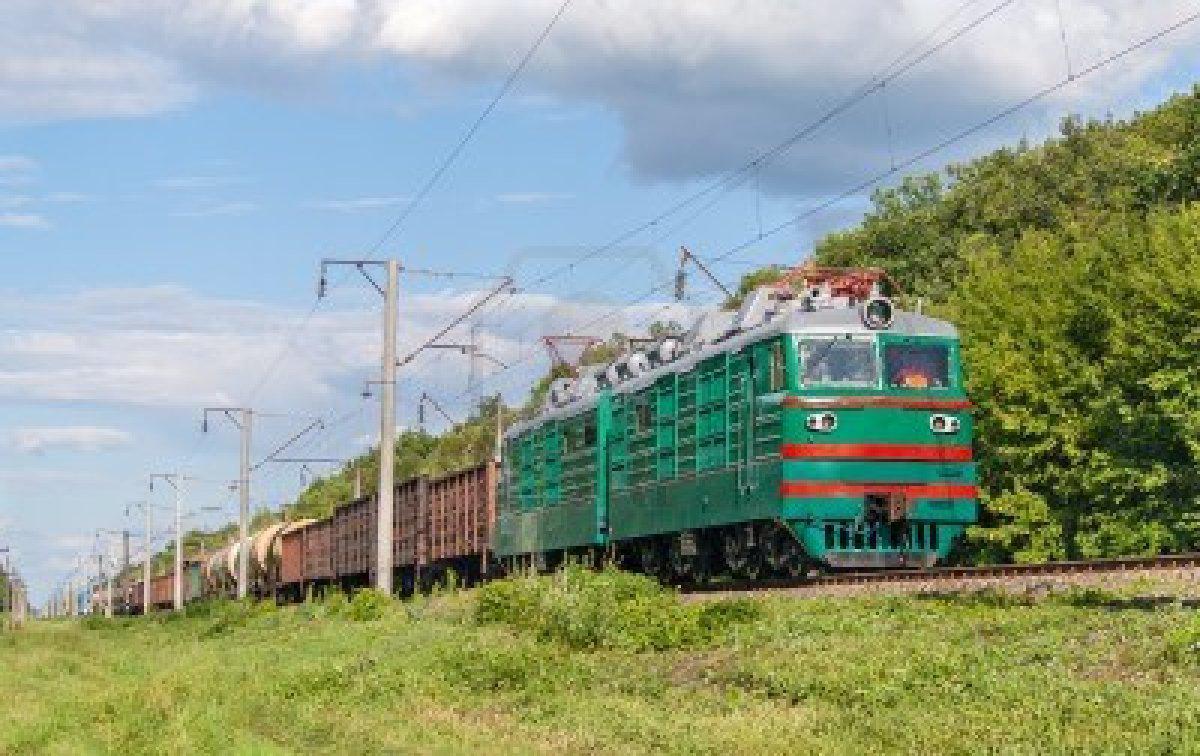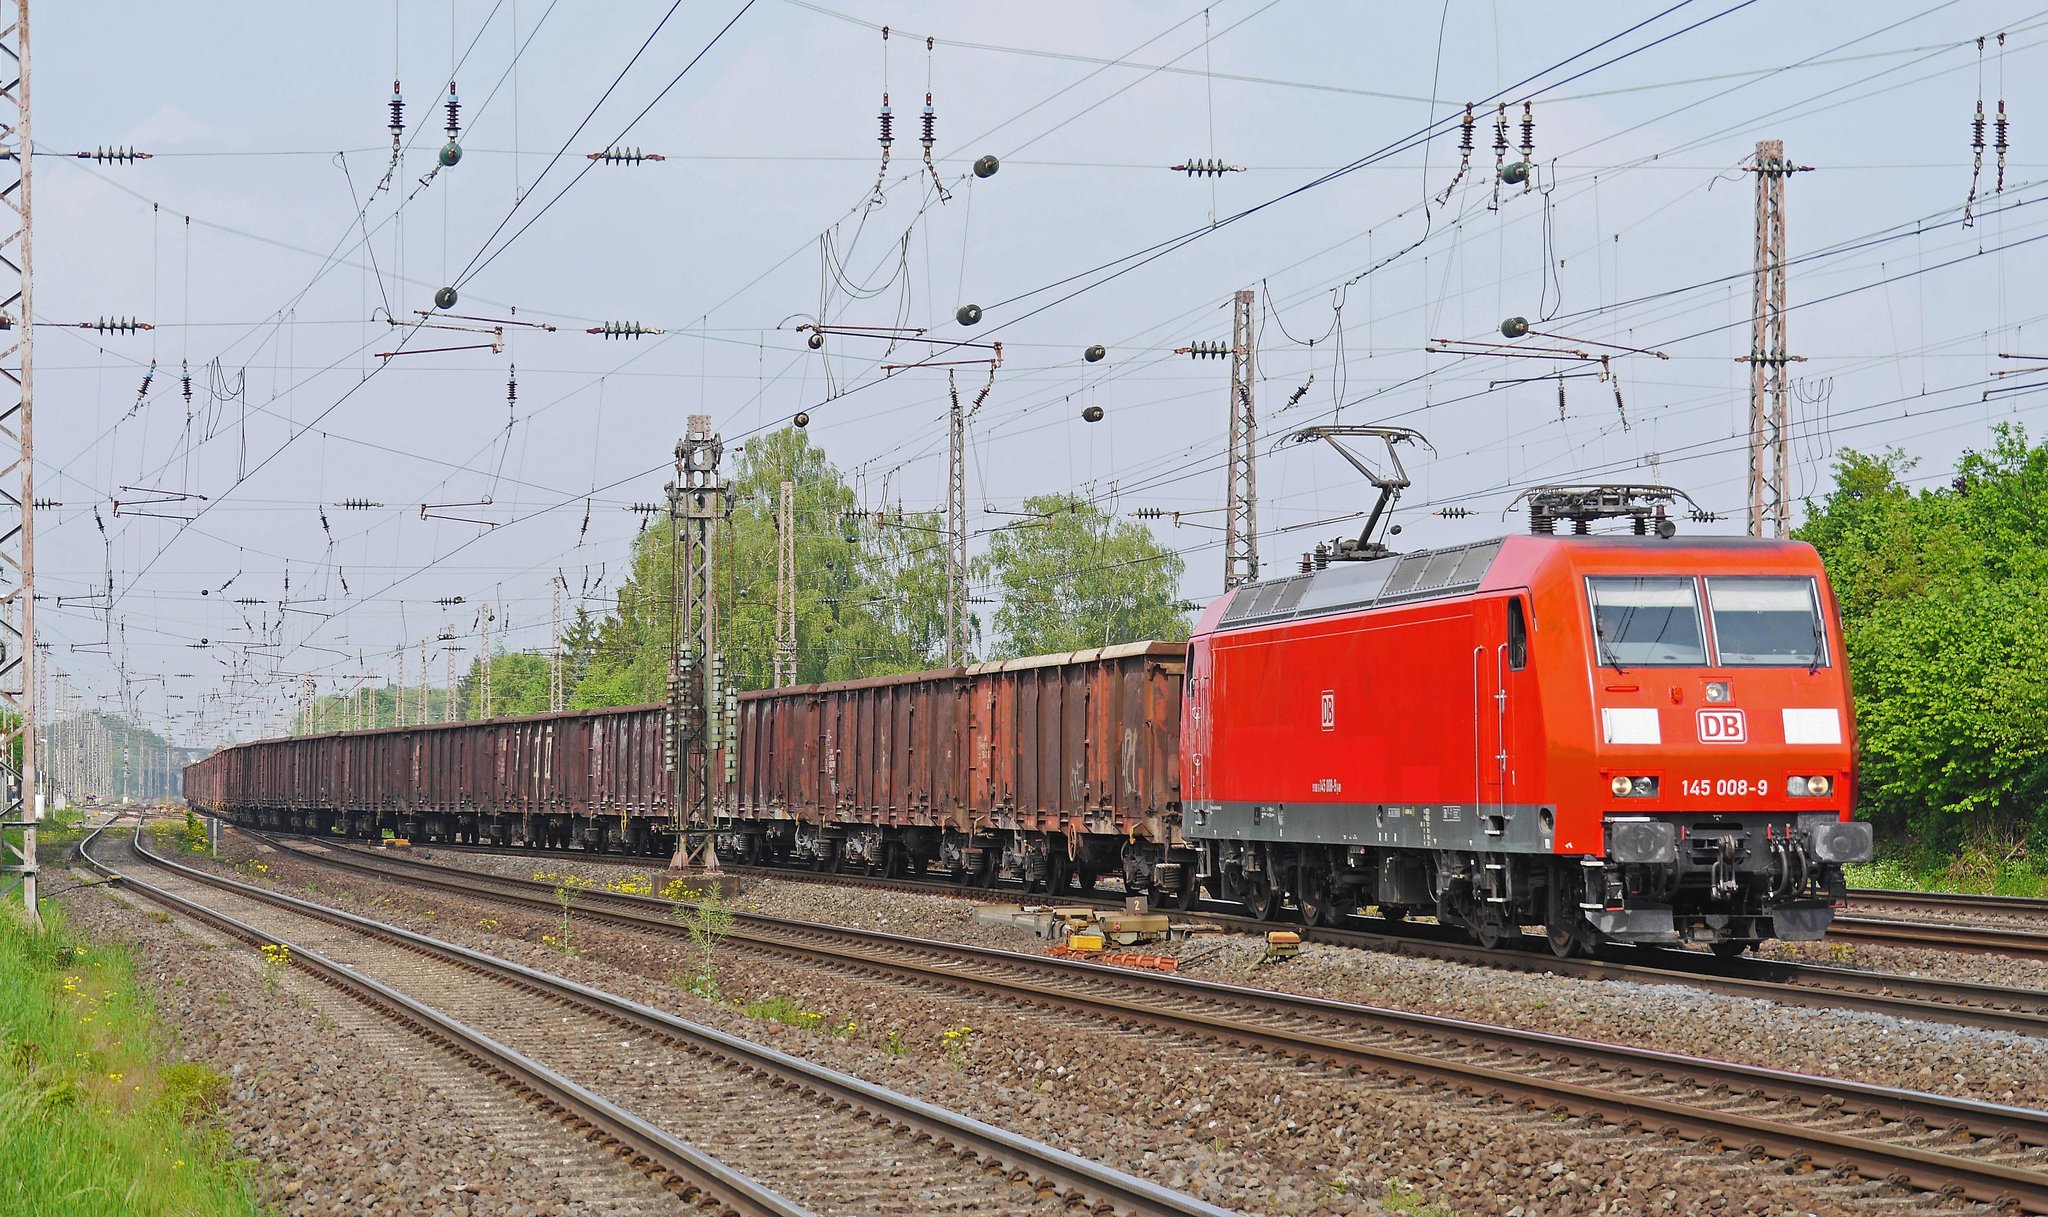The first image is the image on the left, the second image is the image on the right. Examine the images to the left and right. Is the description "At least one image shows a green train with red-orange trim pulling a line of freight cars." accurate? Answer yes or no. Yes. 